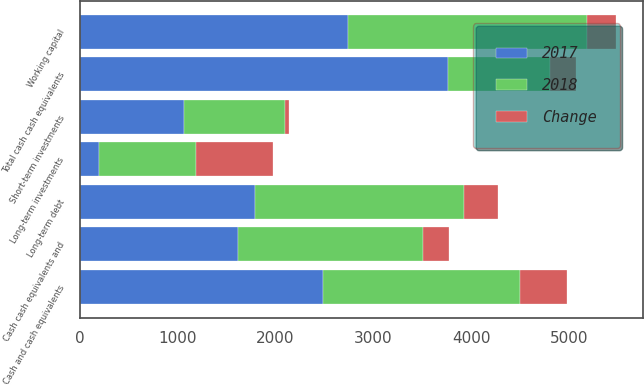Convert chart to OTSL. <chart><loc_0><loc_0><loc_500><loc_500><stacked_bar_chart><ecel><fcel>Working capital<fcel>Cash and cash equivalents<fcel>Short-term investments<fcel>Long-term investments<fcel>Total cash cash equivalents<fcel>Long-term debt<fcel>Cash cash equivalents and<nl><fcel>2017<fcel>2739.3<fcel>2489<fcel>1070.1<fcel>199<fcel>3758.1<fcel>1789.1<fcel>1619.1<nl><fcel>2018<fcel>2446.3<fcel>2006.5<fcel>1026.1<fcel>988.4<fcel>1048.1<fcel>2136.3<fcel>1884.7<nl><fcel>Change<fcel>293<fcel>482.5<fcel>44<fcel>789.4<fcel>262.9<fcel>347.2<fcel>265.6<nl></chart> 